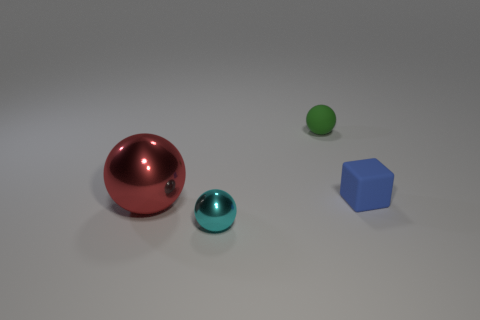Subtract all small balls. How many balls are left? 1 Add 2 gray balls. How many objects exist? 6 Subtract all cyan balls. How many balls are left? 2 Subtract all spheres. How many objects are left? 1 Subtract all red cubes. How many red spheres are left? 1 Subtract 1 cubes. How many cubes are left? 0 Subtract all cyan balls. Subtract all green cylinders. How many balls are left? 2 Subtract all big cylinders. Subtract all small cyan metal balls. How many objects are left? 3 Add 3 rubber blocks. How many rubber blocks are left? 4 Add 4 cyan metallic spheres. How many cyan metallic spheres exist? 5 